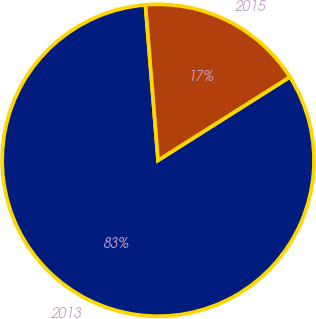Convert chart to OTSL. <chart><loc_0><loc_0><loc_500><loc_500><pie_chart><fcel>2013<fcel>2015<nl><fcel>82.68%<fcel>17.32%<nl></chart> 